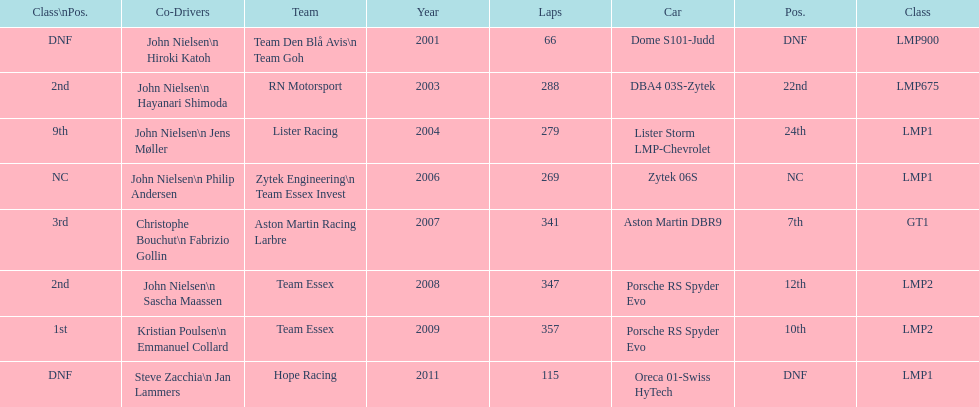Could you parse the entire table as a dict? {'header': ['Class\\nPos.', 'Co-Drivers', 'Team', 'Year', 'Laps', 'Car', 'Pos.', 'Class'], 'rows': [['DNF', 'John Nielsen\\n Hiroki Katoh', 'Team Den Blå Avis\\n Team Goh', '2001', '66', 'Dome S101-Judd', 'DNF', 'LMP900'], ['2nd', 'John Nielsen\\n Hayanari Shimoda', 'RN Motorsport', '2003', '288', 'DBA4 03S-Zytek', '22nd', 'LMP675'], ['9th', 'John Nielsen\\n Jens Møller', 'Lister Racing', '2004', '279', 'Lister Storm LMP-Chevrolet', '24th', 'LMP1'], ['NC', 'John Nielsen\\n Philip Andersen', 'Zytek Engineering\\n Team Essex Invest', '2006', '269', 'Zytek 06S', 'NC', 'LMP1'], ['3rd', 'Christophe Bouchut\\n Fabrizio Gollin', 'Aston Martin Racing Larbre', '2007', '341', 'Aston Martin DBR9', '7th', 'GT1'], ['2nd', 'John Nielsen\\n Sascha Maassen', 'Team Essex', '2008', '347', 'Porsche RS Spyder Evo', '12th', 'LMP2'], ['1st', 'Kristian Poulsen\\n Emmanuel Collard', 'Team Essex', '2009', '357', 'Porsche RS Spyder Evo', '10th', 'LMP2'], ['DNF', 'Steve Zacchia\\n Jan Lammers', 'Hope Racing', '2011', '115', 'Oreca 01-Swiss HyTech', 'DNF', 'LMP1']]} What is the amount races that were competed in? 8. 